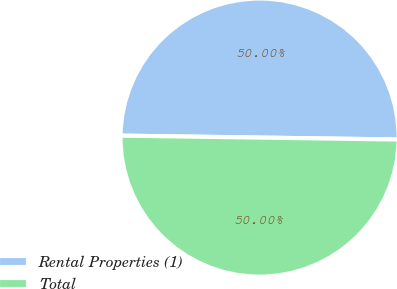<chart> <loc_0><loc_0><loc_500><loc_500><pie_chart><fcel>Rental Properties (1)<fcel>Total<nl><fcel>50.0%<fcel>50.0%<nl></chart> 